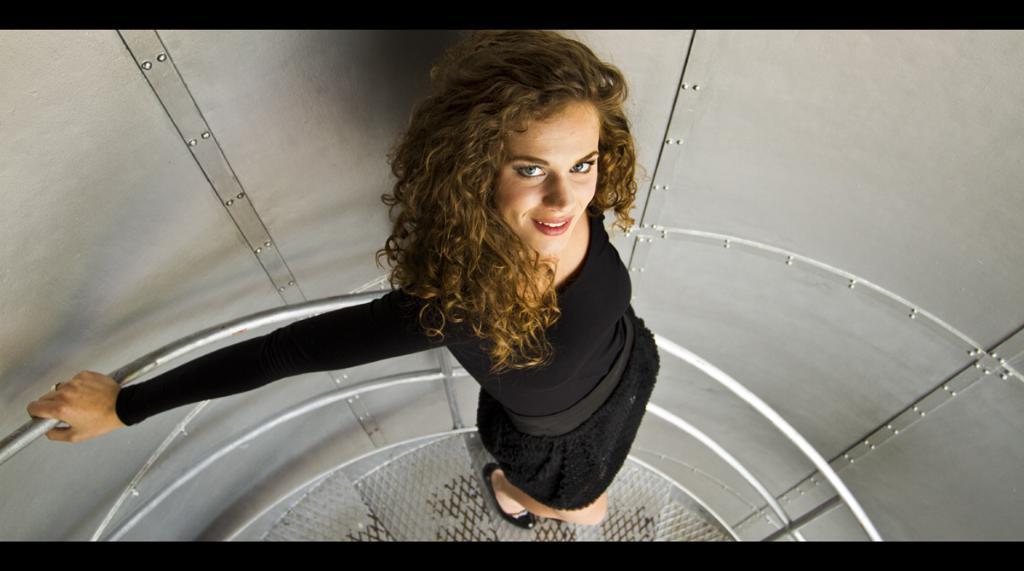Describe this image in one or two sentences. In this image there is a woman standing on the staircase, at the background of the image there is a wall. 